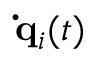<formula> <loc_0><loc_0><loc_500><loc_500>{ \dot { q } } _ { i } ( t )</formula> 